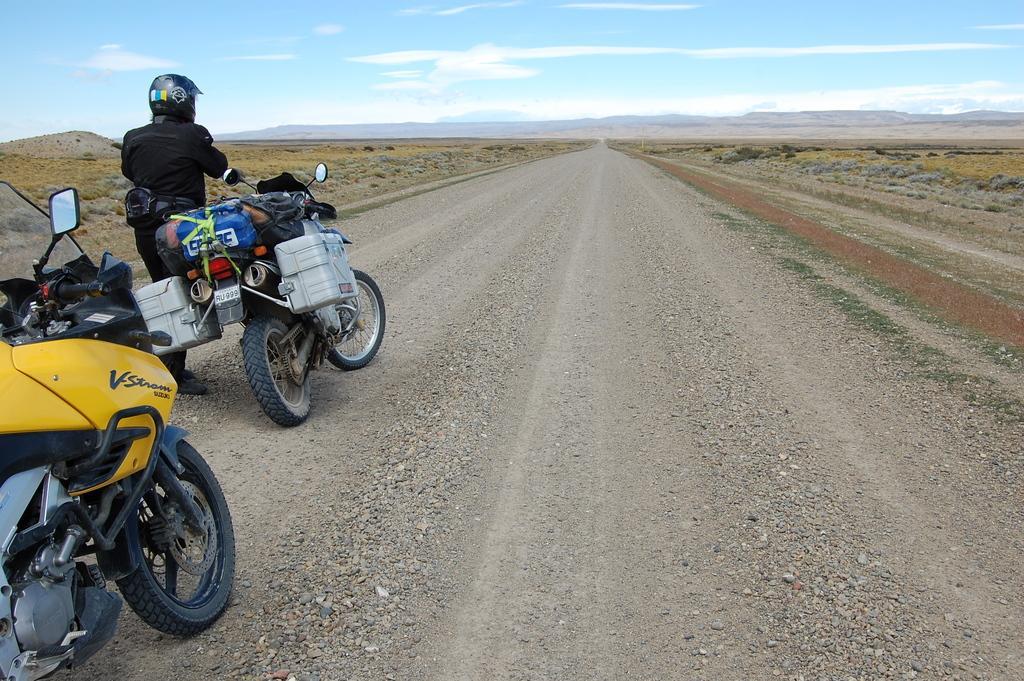Describe this image in one or two sentences. On the left side of the image we can see likes and persons on the road. In the background we can see road, trees, plants, hills, sky and clouds. 